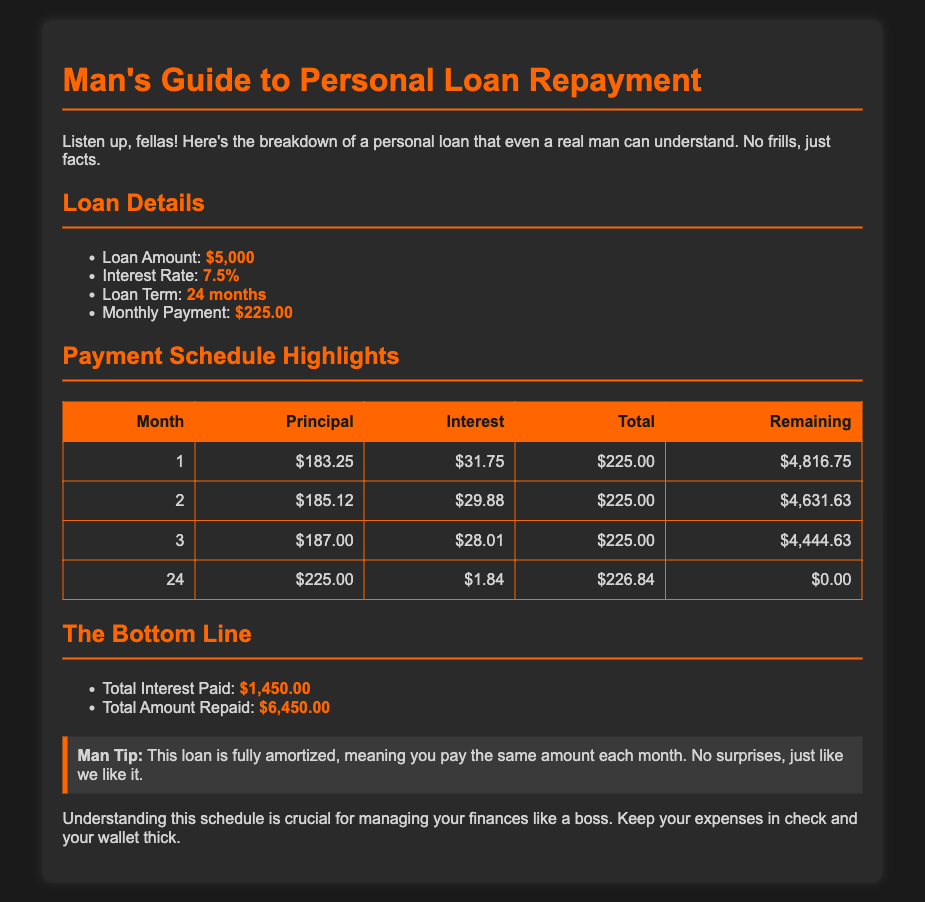What is the loan amount? The loan amount is specified in the document as the initial borrowed sum, which is $5,000.
Answer: $5,000 What is the monthly payment? The monthly payment is the fixed amount due each month throughout the loan term, which is $225.00.
Answer: $225.00 What is the interest rate? The interest rate is the percentage charged on the loan amount, which is noted as 7.5%.
Answer: 7.5% How many months is the loan term? The loan term indicates the duration over which the loan is to be repaid, which is 24 months.
Answer: 24 months What is the total interest paid? The total interest paid represents the complete cost of borrowing over the loan period, amounting to $1,450.00.
Answer: $1,450.00 What is the total amount repaid? The total amount repaid includes both the original loan amount and interest, totaling $6,450.00.
Answer: $6,450.00 In what month is the remaining balance zero? The remaining balance indicates when the loan is fully paid off, which is at the end of the 24th month.
Answer: 24 Which month has the highest principal repayment? The highest principal repayment is found in the final month of the repayment schedule, which is month 24.
Answer: 24 What does fully amortized mean in this context? Fully amortized means that the loan requires equal monthly payments over the entirety of the term, with no surprises.
Answer: Equal payments 